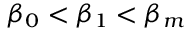<formula> <loc_0><loc_0><loc_500><loc_500>\beta _ { 0 } < \beta _ { 1 } < \beta _ { m }</formula> 